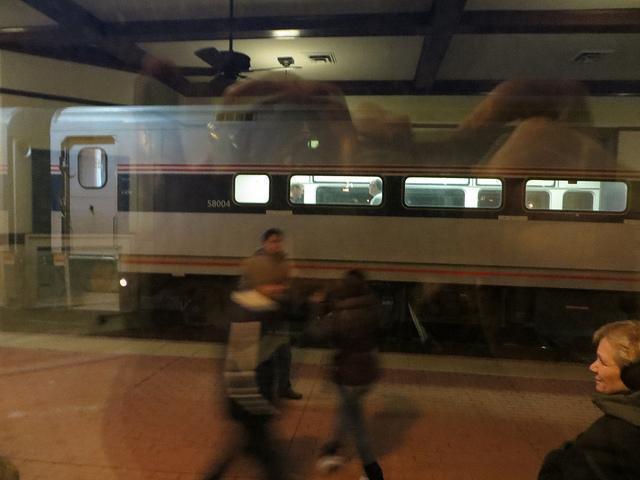How many people are walking around in the train station?
From the following set of four choices, select the accurate answer to respond to the question.
Options: Four, one, three, two. Three. 